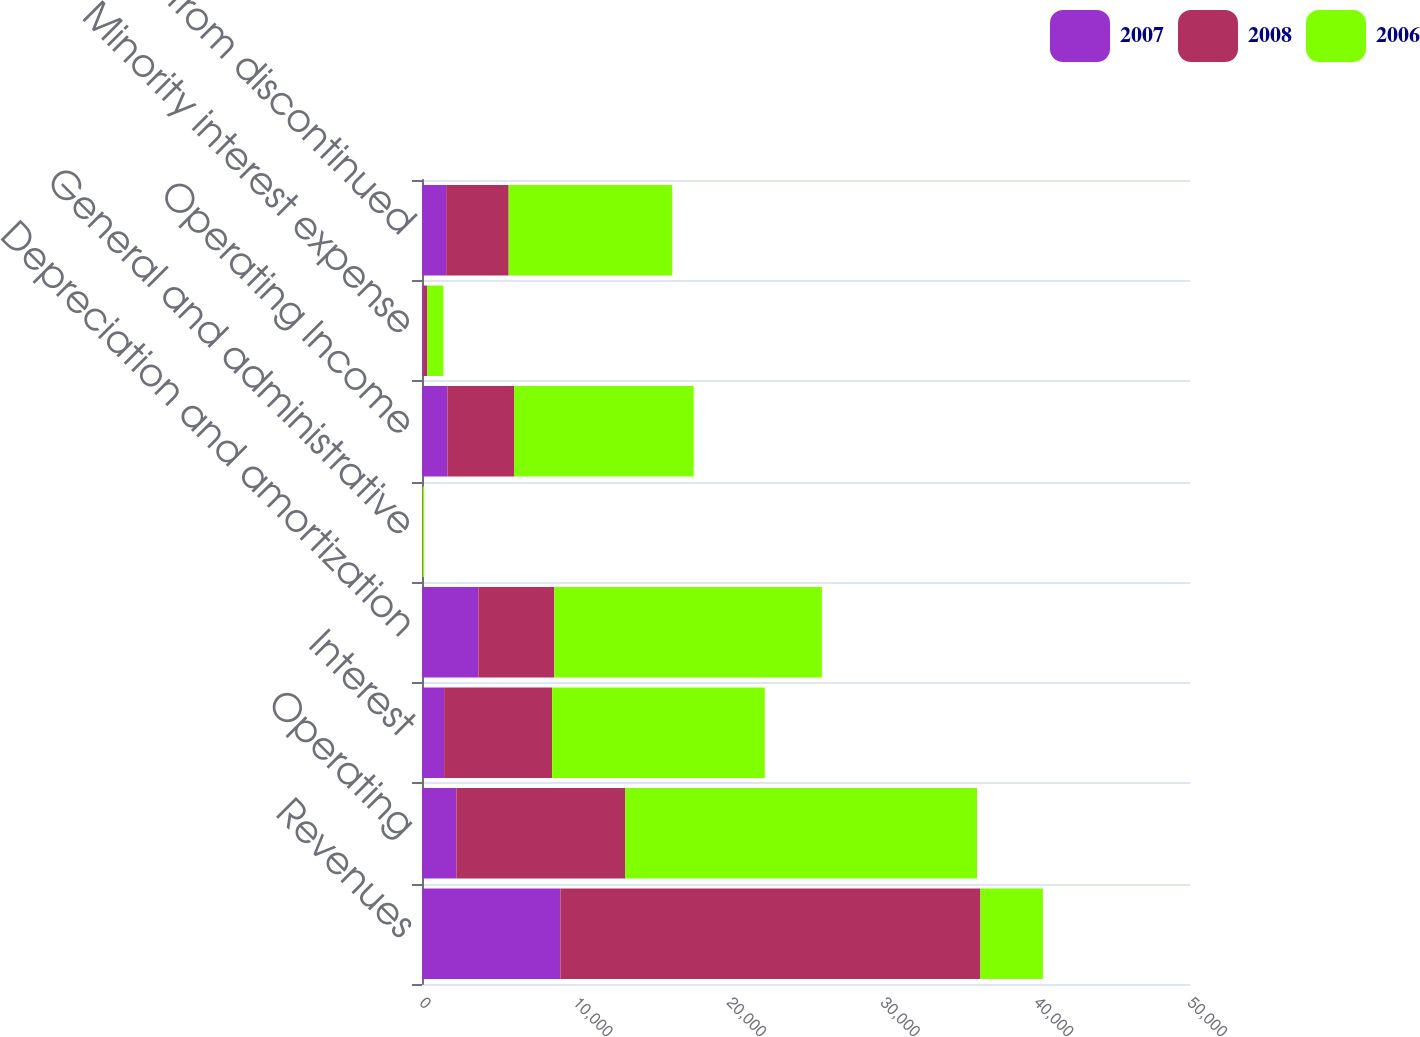Convert chart to OTSL. <chart><loc_0><loc_0><loc_500><loc_500><stacked_bar_chart><ecel><fcel>Revenues<fcel>Operating<fcel>Interest<fcel>Depreciation and amortization<fcel>General and administrative<fcel>Operating Income<fcel>Minority interest expense<fcel>Income from discontinued<nl><fcel>2007<fcel>9012<fcel>2242<fcel>1440<fcel>3673<fcel>2<fcel>1655<fcel>82<fcel>1573<nl><fcel>2008<fcel>27343<fcel>10997<fcel>7030<fcel>4941<fcel>38<fcel>4337<fcel>269<fcel>4068<nl><fcel>2006<fcel>4068<fcel>22898<fcel>13848<fcel>17422<fcel>105<fcel>11696<fcel>1042<fcel>10654<nl></chart> 